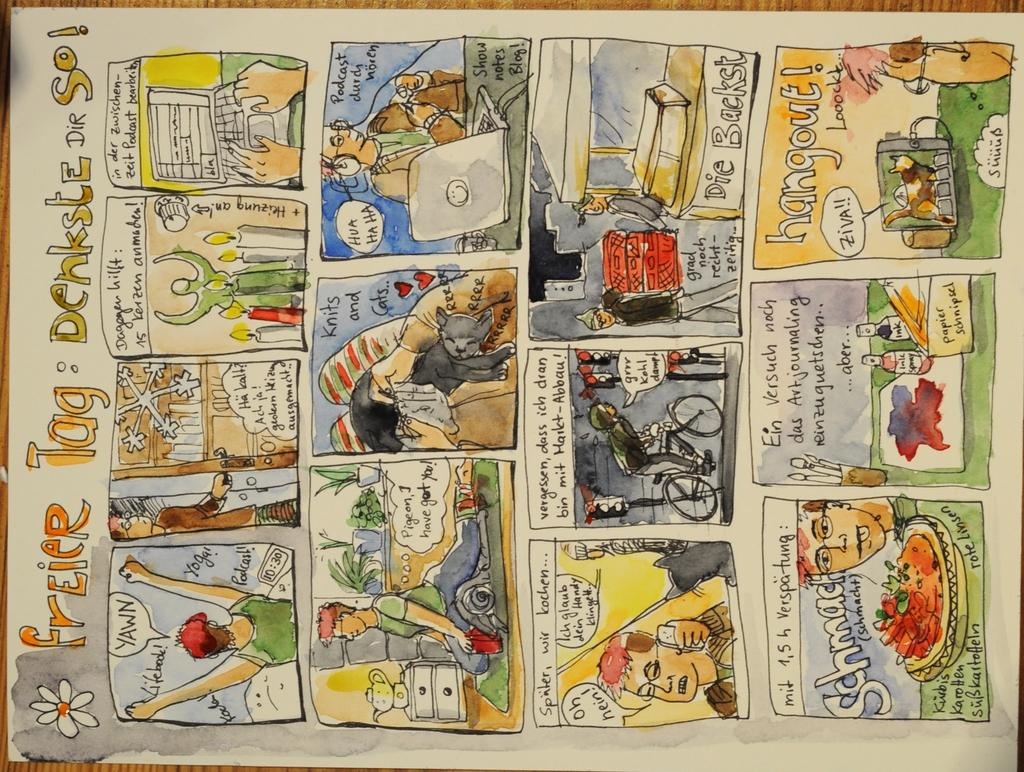<image>
Present a compact description of the photo's key features. Comic strip titled Frier Tag showing a person's life. 